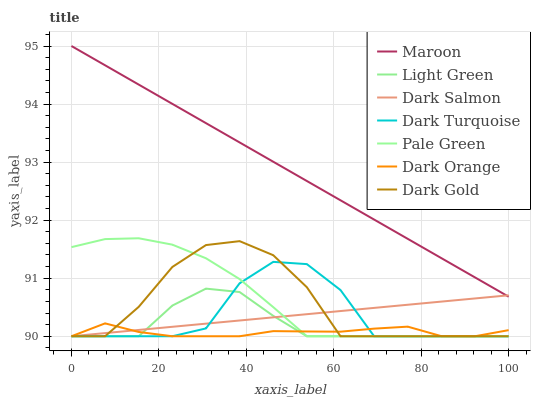Does Dark Orange have the minimum area under the curve?
Answer yes or no. Yes. Does Maroon have the maximum area under the curve?
Answer yes or no. Yes. Does Dark Gold have the minimum area under the curve?
Answer yes or no. No. Does Dark Gold have the maximum area under the curve?
Answer yes or no. No. Is Dark Salmon the smoothest?
Answer yes or no. Yes. Is Dark Turquoise the roughest?
Answer yes or no. Yes. Is Dark Gold the smoothest?
Answer yes or no. No. Is Dark Gold the roughest?
Answer yes or no. No. Does Dark Orange have the lowest value?
Answer yes or no. Yes. Does Maroon have the lowest value?
Answer yes or no. No. Does Maroon have the highest value?
Answer yes or no. Yes. Does Dark Gold have the highest value?
Answer yes or no. No. Is Dark Gold less than Maroon?
Answer yes or no. Yes. Is Maroon greater than Dark Gold?
Answer yes or no. Yes. Does Dark Salmon intersect Dark Gold?
Answer yes or no. Yes. Is Dark Salmon less than Dark Gold?
Answer yes or no. No. Is Dark Salmon greater than Dark Gold?
Answer yes or no. No. Does Dark Gold intersect Maroon?
Answer yes or no. No. 